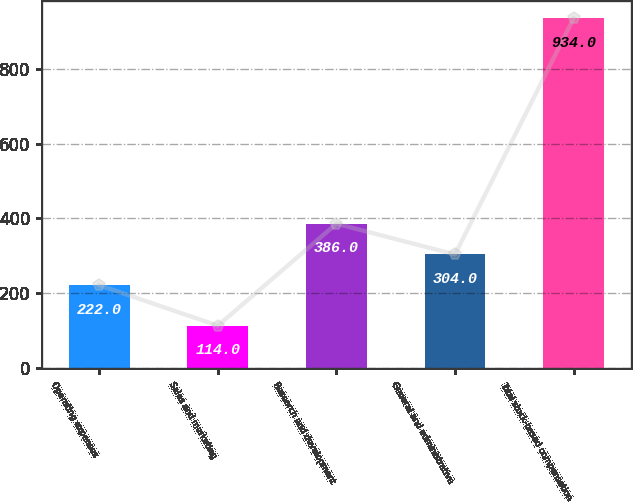Convert chart to OTSL. <chart><loc_0><loc_0><loc_500><loc_500><bar_chart><fcel>Operating expenses<fcel>Sales and marketing<fcel>Research and development<fcel>General and administrative<fcel>Total stock-based compensation<nl><fcel>222<fcel>114<fcel>386<fcel>304<fcel>934<nl></chart> 